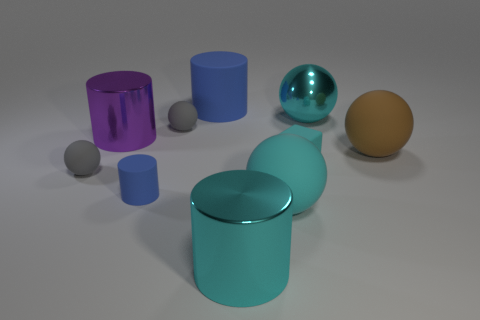Subtract all large rubber cylinders. How many cylinders are left? 3 Subtract 3 cylinders. How many cylinders are left? 1 Subtract all blue cylinders. How many cylinders are left? 2 Subtract 0 blue blocks. How many objects are left? 10 Subtract all cubes. How many objects are left? 9 Subtract all blue spheres. Subtract all yellow blocks. How many spheres are left? 5 Subtract all red cubes. How many gray spheres are left? 2 Subtract all cyan metallic cylinders. Subtract all purple cylinders. How many objects are left? 8 Add 2 tiny blue matte things. How many tiny blue matte things are left? 3 Add 1 cyan metallic objects. How many cyan metallic objects exist? 3 